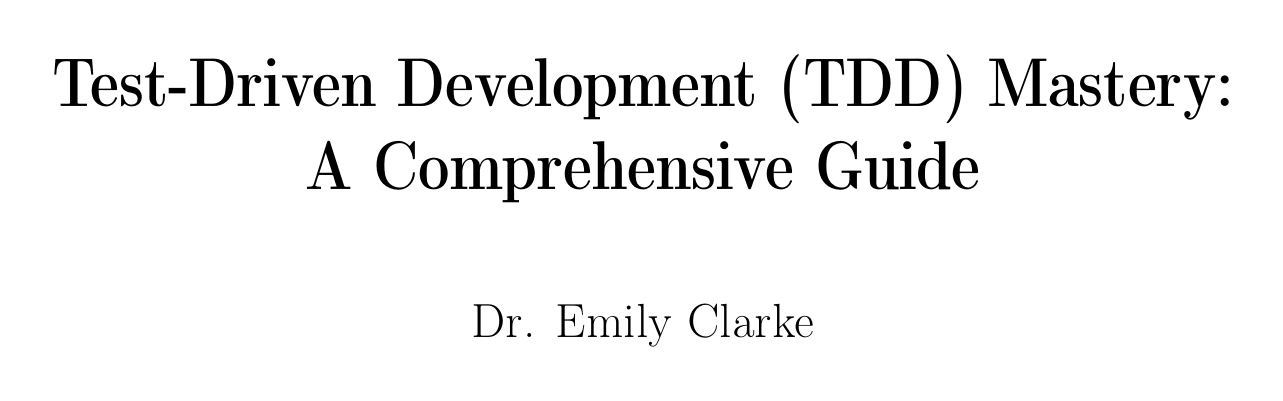What is the title of the handbook? The title of the handbook is provided at the beginning of the document as "Test-Driven Development (TDD) Mastery: A Comprehensive Guide."
Answer: Test-Driven Development (TDD) Mastery: A Comprehensive Guide Who is the author of the document? The author is mentioned right below the title, identifying Dr. Emily Clarke as the writer of the handbook.
Answer: Dr. Emily Clarke How many chapters are included in the document? The document lists a total of nine chapters, covering various aspects of TDD.
Answer: Nine What section covers TDD in Java? The specific section that focuses on Java is located under the chapter dedicated to TDD in Java.
Answer: TDD in Java Which testing framework is used for TDD in Python? The document identifies pytest as the framework specifically mentioned for implementing TDD in Python projects.
Answer: pytest What are two common pitfalls in TDD mentioned in the appendices? The appendices list several pitfalls, of which two are "Overcomplicating Tests" and "Ignoring Edge Cases."
Answer: Overcomplicating Tests, Ignoring Edge Cases Which chapter discusses Advanced TDD Techniques? The chapter that deals with advanced techniques in TDD is titled "Advanced TDD Techniques."
Answer: Advanced TDD Techniques What type of testing is emphasized for microservices in the document? The document discusses "Contract Testing with Pact" as a key technique for testing in microservices.
Answer: Contract Testing with Pact How many resources are listed in the document? The document outlines two main resource sections, covering recommended readings and online communities, but does not specify a numerical count.
Answer: Two 